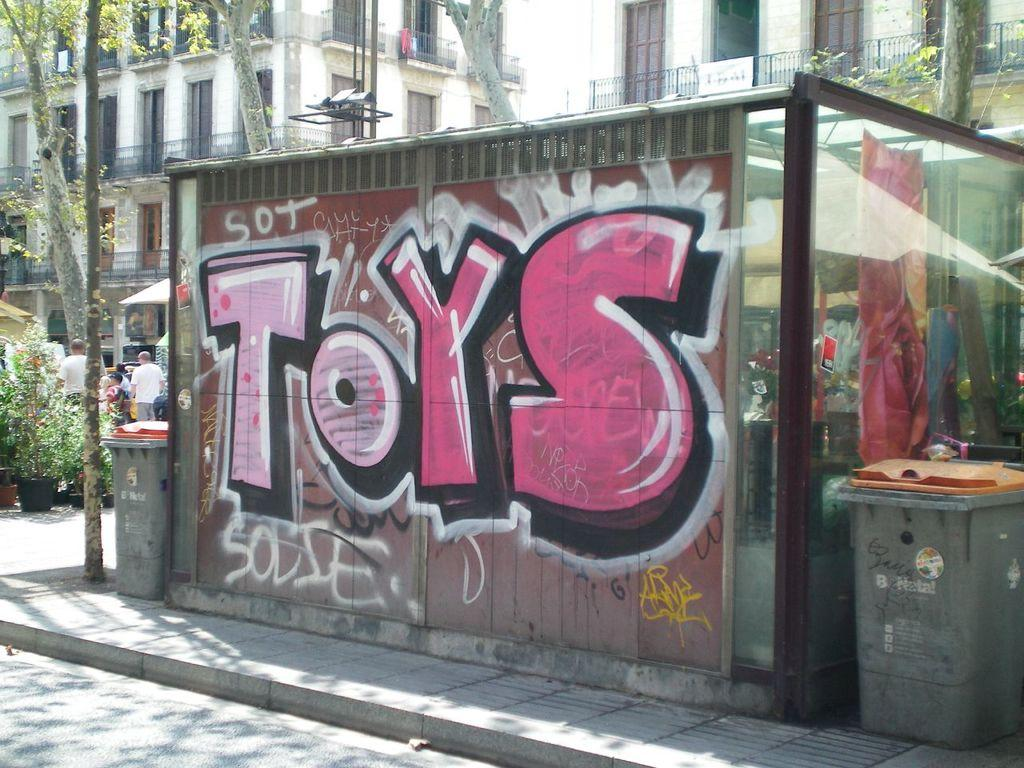<image>
Give a short and clear explanation of the subsequent image. Toys designed on a wall outside in pink. 